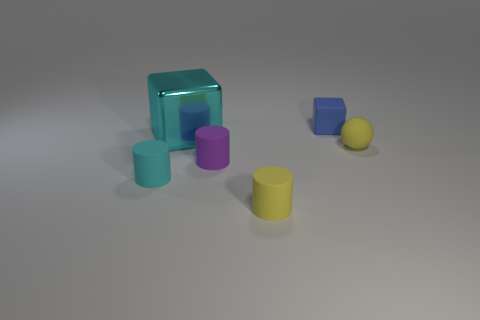Add 3 cyan metal balls. How many objects exist? 9 Subtract all balls. How many objects are left? 5 Subtract 0 yellow cubes. How many objects are left? 6 Subtract all blue objects. Subtract all yellow rubber spheres. How many objects are left? 4 Add 1 big objects. How many big objects are left? 2 Add 2 tiny gray rubber blocks. How many tiny gray rubber blocks exist? 2 